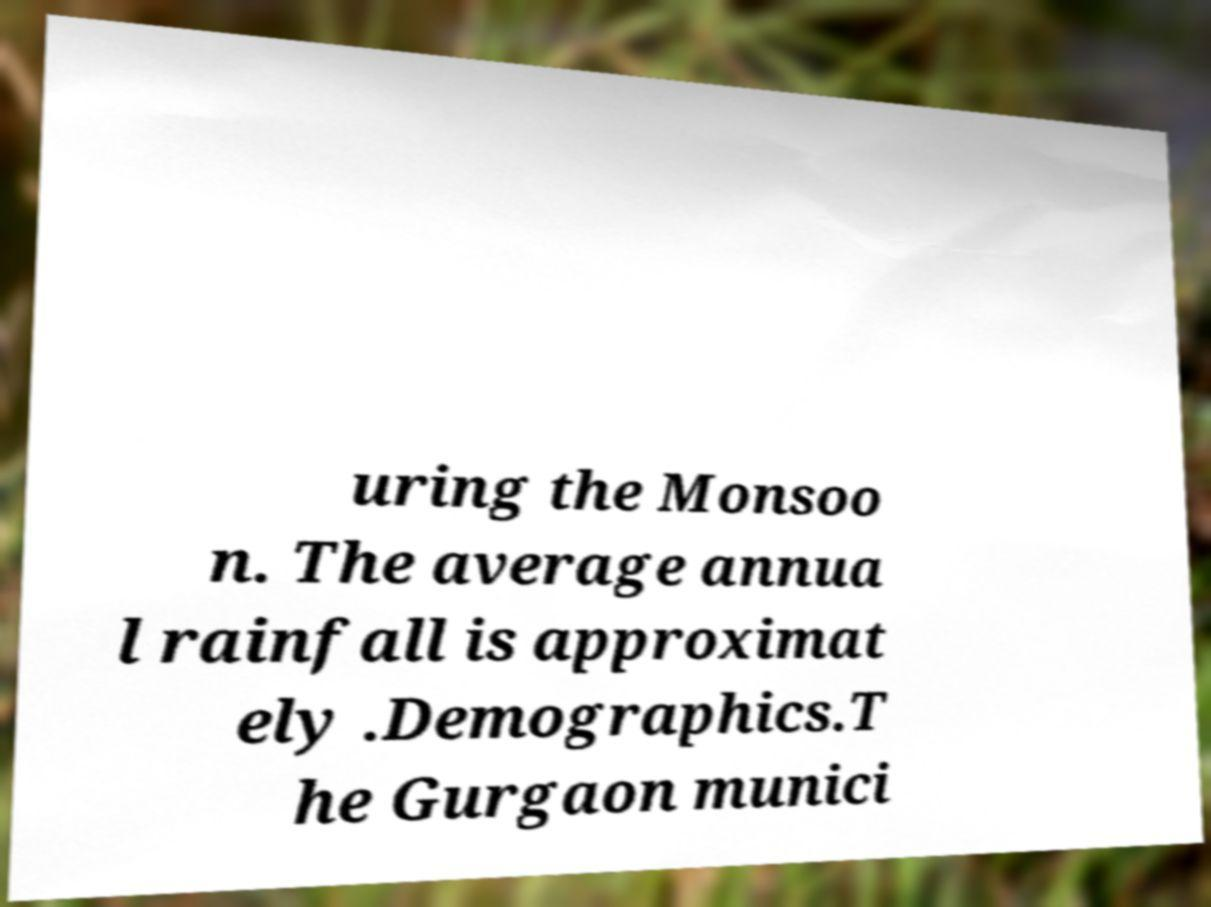What messages or text are displayed in this image? I need them in a readable, typed format. uring the Monsoo n. The average annua l rainfall is approximat ely .Demographics.T he Gurgaon munici 